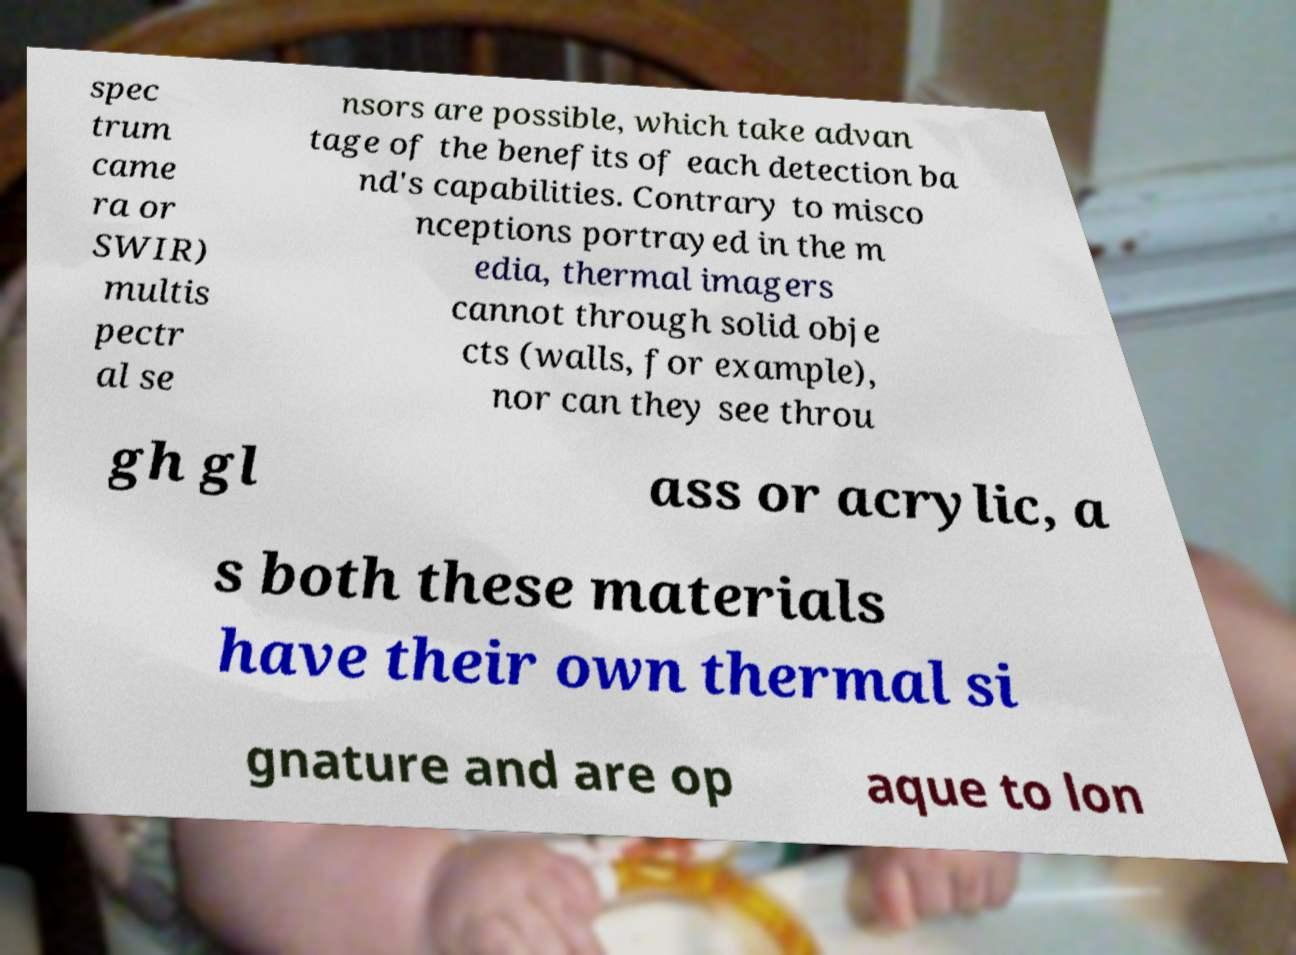Please identify and transcribe the text found in this image. spec trum came ra or SWIR) multis pectr al se nsors are possible, which take advan tage of the benefits of each detection ba nd's capabilities. Contrary to misco nceptions portrayed in the m edia, thermal imagers cannot through solid obje cts (walls, for example), nor can they see throu gh gl ass or acrylic, a s both these materials have their own thermal si gnature and are op aque to lon 